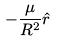Convert formula to latex. <formula><loc_0><loc_0><loc_500><loc_500>- \frac { \mu } { R ^ { 2 } } \hat { r }</formula> 